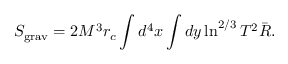<formula> <loc_0><loc_0><loc_500><loc_500>S _ { g r a v } = 2 M ^ { 3 } r _ { c } \int d ^ { 4 } x \int d y \ln ^ { 2 / 3 } T ^ { 2 } \bar { R } .</formula> 